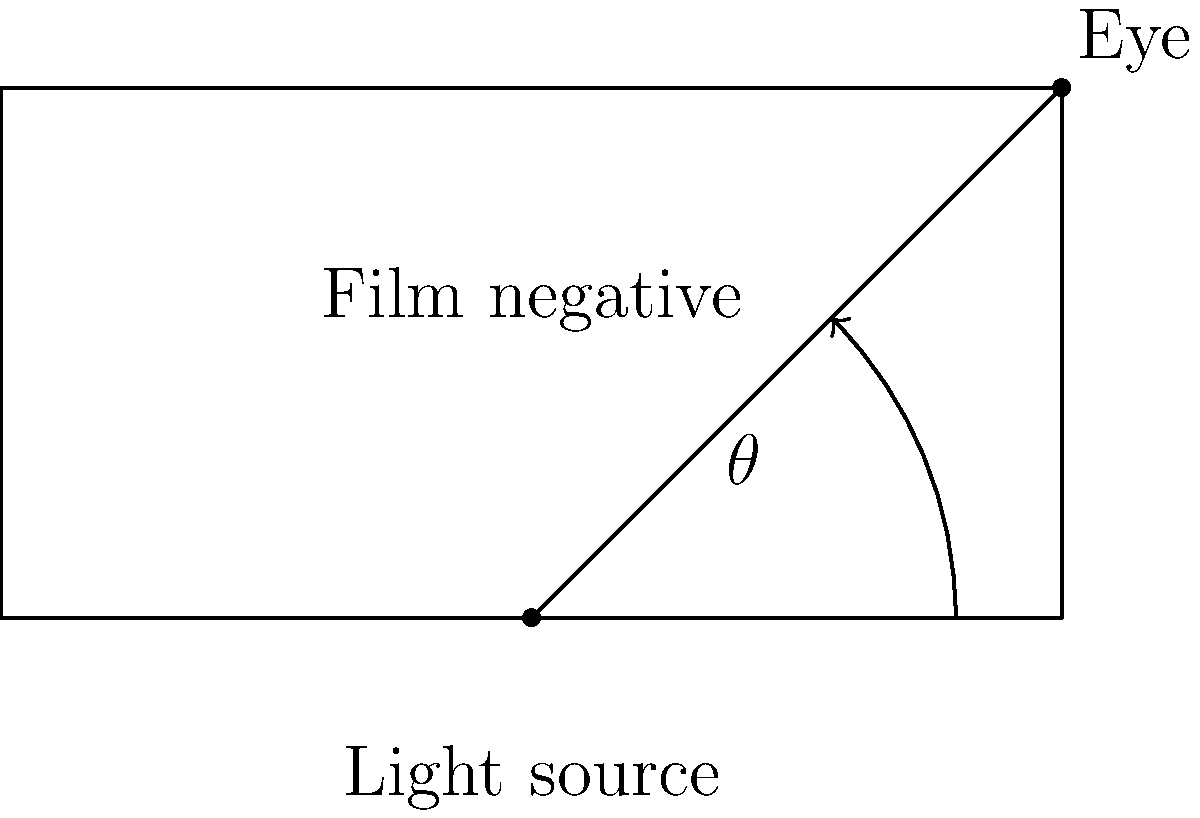What is the optimal viewing angle $\theta$ for assessing film negatives during development to minimize glare and maximize visibility of details? To determine the optimal viewing angle for assessing film negatives during development, we need to consider several factors:

1. Glare reduction: A steep viewing angle helps minimize glare from the light source.
2. Detail visibility: An angle that allows enough light to pass through the negative while still providing contrast is crucial.
3. Practical considerations: The angle should be comfortable for extended viewing periods.

Taking these factors into account:

1. A viewing angle of 90° (directly above the negative) would maximize glare, making it difficult to see details.
2. A very shallow angle (close to 0°) would reduce visibility due to limited light passing through the negative.
3. The optimal angle is typically found between 30° and 60° from the horizontal.
4. Within this range, 45° is often considered the best compromise, as it:
   a. Significantly reduces glare
   b. Allows sufficient light to pass through the negative
   c. Provides good contrast for assessing details
   d. Is comfortable for extended viewing

Therefore, the optimal viewing angle $\theta$ for assessing film negatives during development is approximately 45°.
Answer: 45° 